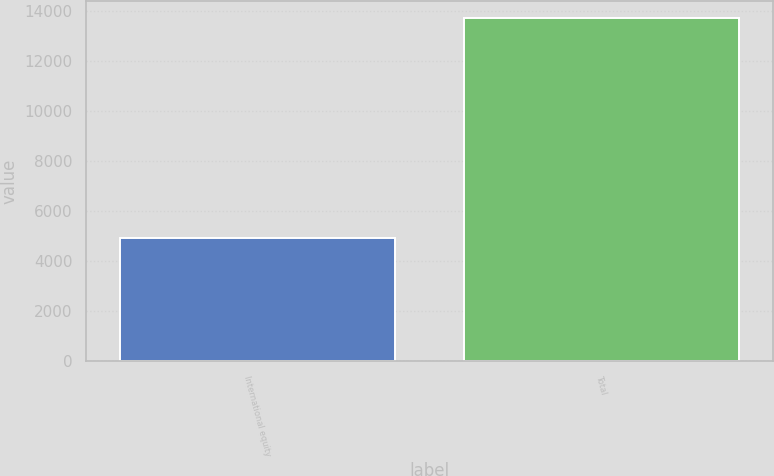<chart> <loc_0><loc_0><loc_500><loc_500><bar_chart><fcel>International equity<fcel>Total<nl><fcel>4912<fcel>13730<nl></chart> 